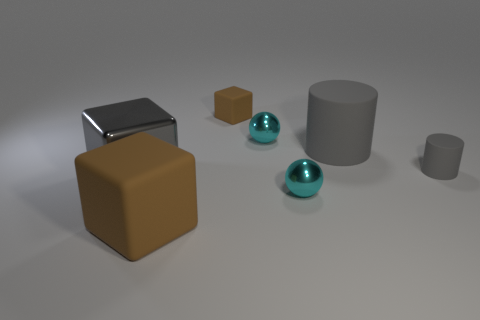Add 2 big purple metal cubes. How many objects exist? 9 Subtract all spheres. How many objects are left? 5 Add 3 brown matte objects. How many brown matte objects are left? 5 Add 5 small metal things. How many small metal things exist? 7 Subtract 0 yellow blocks. How many objects are left? 7 Subtract all gray things. Subtract all blocks. How many objects are left? 1 